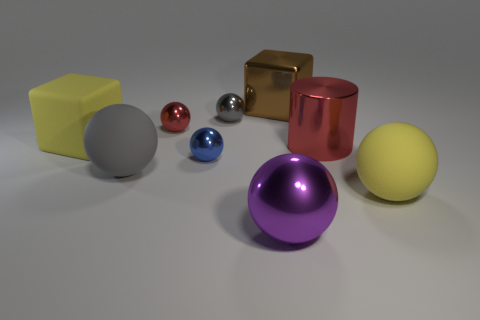How many tiny red metallic objects have the same shape as the gray shiny object?
Your answer should be very brief. 1. Are there the same number of spheres behind the tiny blue metallic object and purple spheres behind the yellow matte block?
Your response must be concise. No. Is there another big red thing that has the same material as the large red thing?
Keep it short and to the point. No. Is the large red object made of the same material as the large yellow cube?
Offer a very short reply. No. How many blue objects are metal blocks or rubber balls?
Make the answer very short. 0. Are there more large brown metal cubes that are in front of the cylinder than matte spheres?
Your answer should be compact. No. Is there a big cylinder that has the same color as the big metallic ball?
Provide a succinct answer. No. What is the size of the brown metallic block?
Make the answer very short. Large. Do the metallic cube and the big metal sphere have the same color?
Provide a short and direct response. No. How many things are either blue balls or big spheres that are to the right of the large metal cube?
Make the answer very short. 2. 